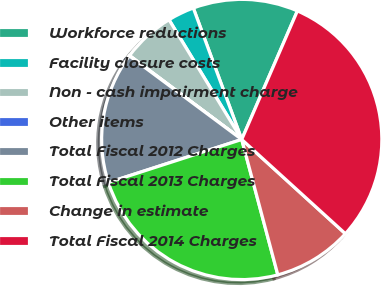<chart> <loc_0><loc_0><loc_500><loc_500><pie_chart><fcel>Workforce reductions<fcel>Facility closure costs<fcel>Non - cash impairment charge<fcel>Other items<fcel>Total Fiscal 2012 Charges<fcel>Total Fiscal 2013 Charges<fcel>Change in estimate<fcel>Total Fiscal 2014 Charges<nl><fcel>12.12%<fcel>3.07%<fcel>6.09%<fcel>0.05%<fcel>15.14%<fcel>24.18%<fcel>9.11%<fcel>30.24%<nl></chart> 